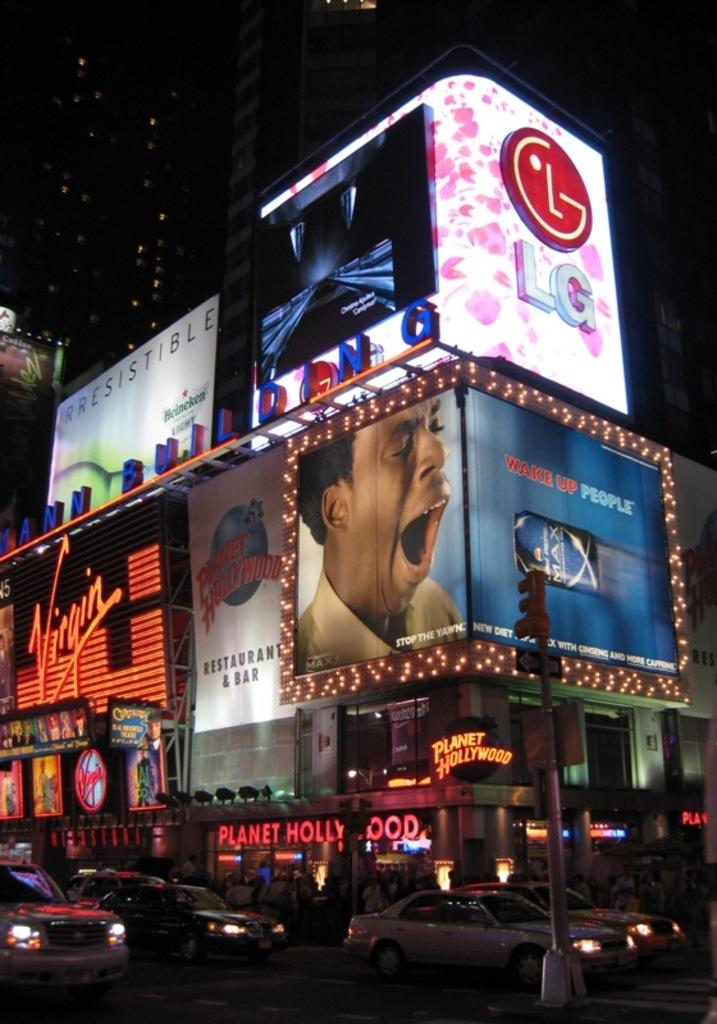<image>
Share a concise interpretation of the image provided. Some electric signs, one of which reads WAKE UP PEOPLE. 